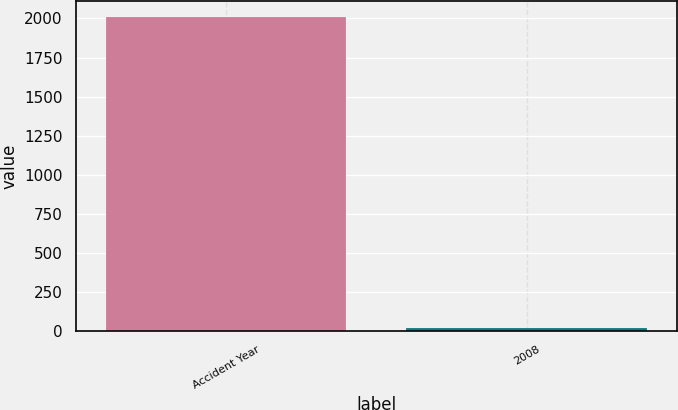Convert chart to OTSL. <chart><loc_0><loc_0><loc_500><loc_500><bar_chart><fcel>Accident Year<fcel>2008<nl><fcel>2009<fcel>18<nl></chart> 